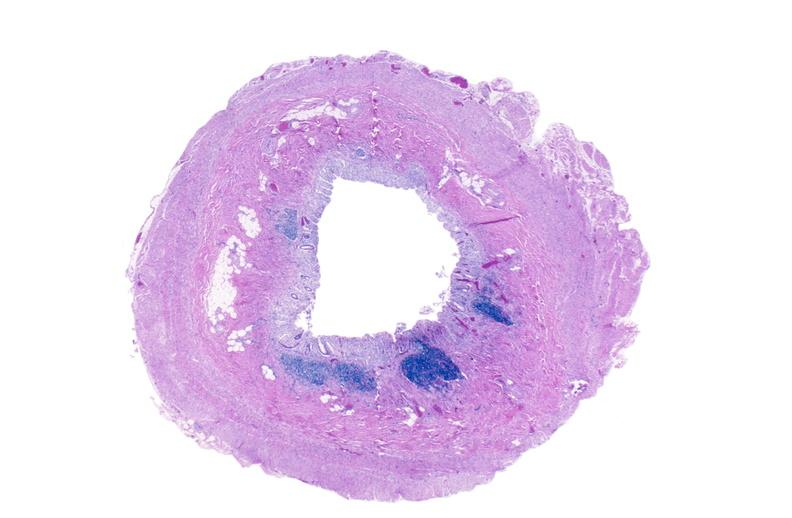what is present?
Answer the question using a single word or phrase. Gastrointestinal 